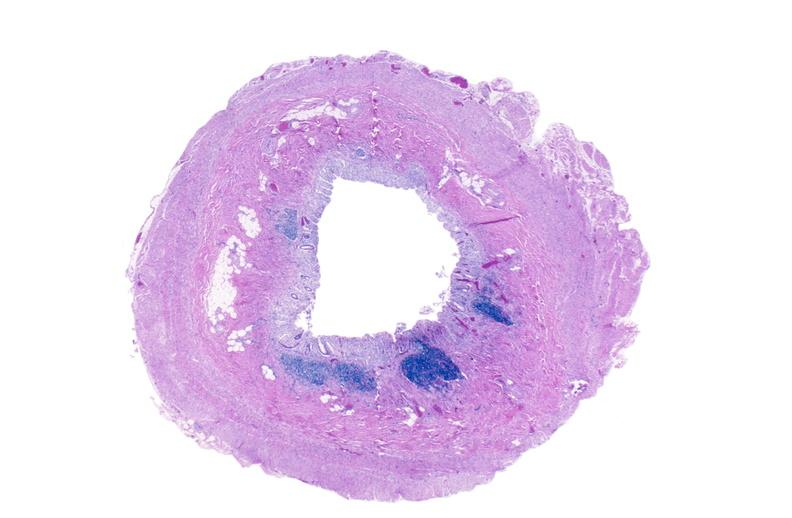what is present?
Answer the question using a single word or phrase. Gastrointestinal 